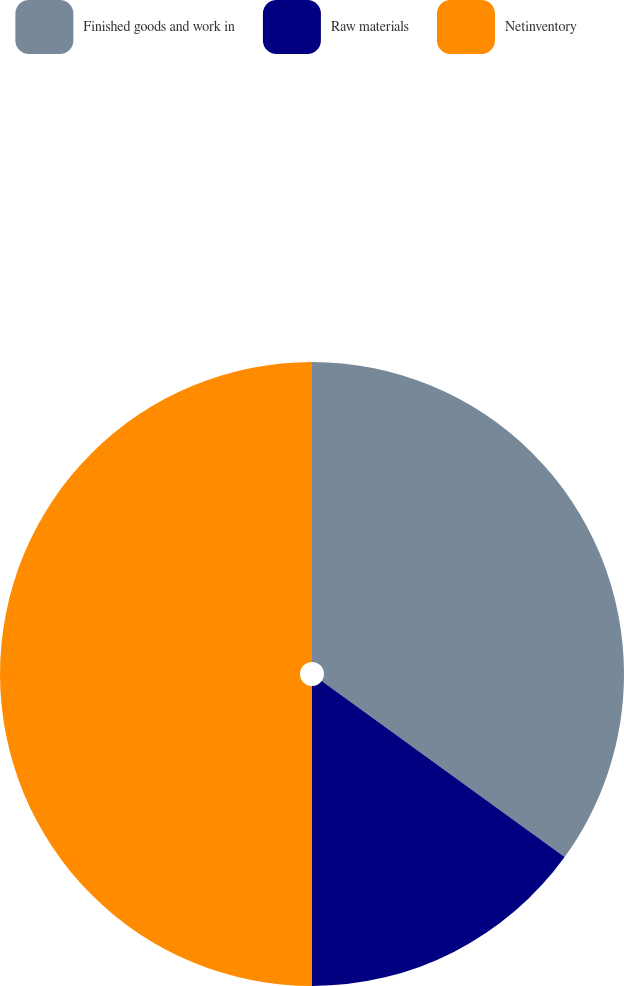Convert chart. <chart><loc_0><loc_0><loc_500><loc_500><pie_chart><fcel>Finished goods and work in<fcel>Raw materials<fcel>Netinventory<nl><fcel>34.98%<fcel>15.02%<fcel>50.0%<nl></chart> 